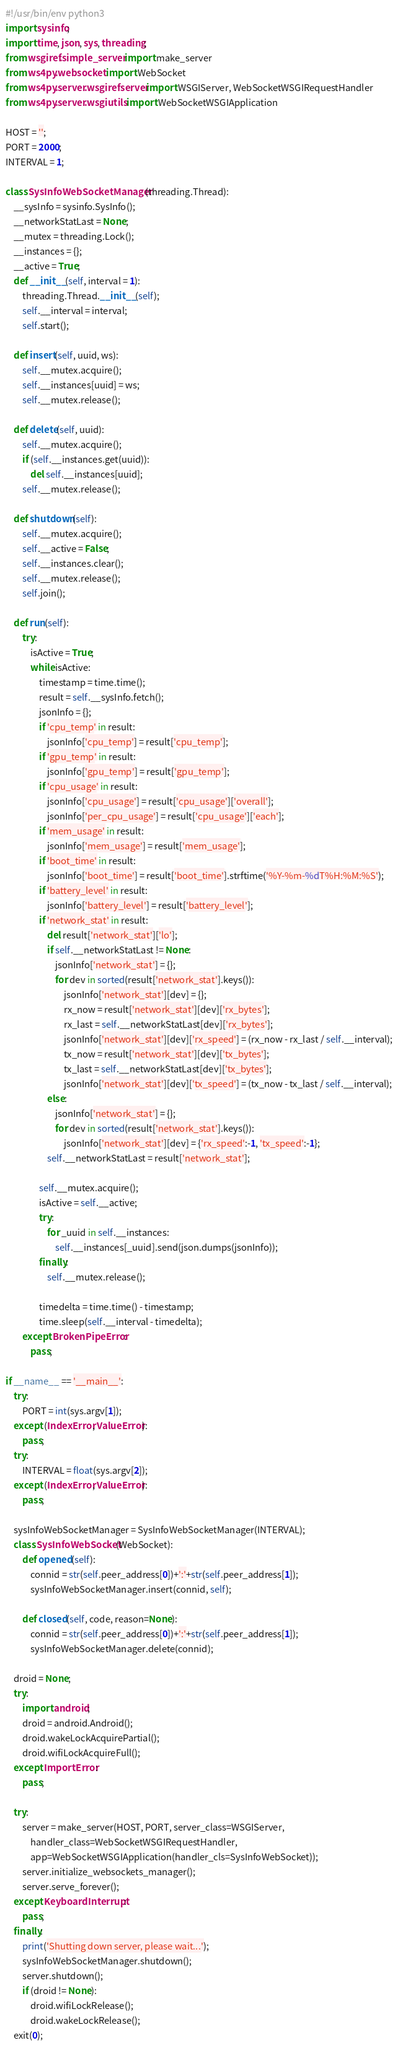Convert code to text. <code><loc_0><loc_0><loc_500><loc_500><_Python_>#!/usr/bin/env python3
import sysinfo;
import time, json, sys, threading;
from wsgiref.simple_server import make_server
from ws4py.websocket import WebSocket
from ws4py.server.wsgirefserver import WSGIServer, WebSocketWSGIRequestHandler
from ws4py.server.wsgiutils import WebSocketWSGIApplication

HOST = '';
PORT = 2000;
INTERVAL = 1;

class SysInfoWebSocketManager(threading.Thread):
    __sysInfo = sysinfo.SysInfo();
    __networkStatLast = None;
    __mutex = threading.Lock();
    __instances = {};
    __active = True;
    def __init__(self, interval = 1):
        threading.Thread.__init__(self);
        self.__interval = interval;
        self.start();

    def insert(self, uuid, ws):
        self.__mutex.acquire();
        self.__instances[uuid] = ws;
        self.__mutex.release();

    def delete(self, uuid):
        self.__mutex.acquire();
        if (self.__instances.get(uuid)):
            del self.__instances[uuid];
        self.__mutex.release();

    def shutdown(self):
        self.__mutex.acquire();
        self.__active = False;
        self.__instances.clear();
        self.__mutex.release();
        self.join();

    def run(self):
        try:
            isActive = True;
            while isActive:
                timestamp = time.time();
                result = self.__sysInfo.fetch();
                jsonInfo = {};
                if 'cpu_temp' in result:
                    jsonInfo['cpu_temp'] = result['cpu_temp'];
                if 'gpu_temp' in result:
                    jsonInfo['gpu_temp'] = result['gpu_temp'];
                if 'cpu_usage' in result:
                    jsonInfo['cpu_usage'] = result['cpu_usage']['overall'];
                    jsonInfo['per_cpu_usage'] = result['cpu_usage']['each'];
                if 'mem_usage' in result:
                    jsonInfo['mem_usage'] = result['mem_usage'];
                if 'boot_time' in result:
                    jsonInfo['boot_time'] = result['boot_time'].strftime('%Y-%m-%dT%H:%M:%S');
                if 'battery_level' in result:
                    jsonInfo['battery_level'] = result['battery_level'];
                if 'network_stat' in result:
                    del result['network_stat']['lo'];
                    if self.__networkStatLast != None:
                        jsonInfo['network_stat'] = {};
                        for dev in sorted(result['network_stat'].keys()):
                            jsonInfo['network_stat'][dev] = {};
                            rx_now = result['network_stat'][dev]['rx_bytes'];
                            rx_last = self.__networkStatLast[dev]['rx_bytes'];
                            jsonInfo['network_stat'][dev]['rx_speed'] = (rx_now - rx_last / self.__interval);
                            tx_now = result['network_stat'][dev]['tx_bytes'];
                            tx_last = self.__networkStatLast[dev]['tx_bytes'];
                            jsonInfo['network_stat'][dev]['tx_speed'] = (tx_now - tx_last / self.__interval);
                    else:
                        jsonInfo['network_stat'] = {};
                        for dev in sorted(result['network_stat'].keys()):
                            jsonInfo['network_stat'][dev] = {'rx_speed':-1, 'tx_speed':-1};
                    self.__networkStatLast = result['network_stat'];

                self.__mutex.acquire();
                isActive = self.__active;
                try:
                    for _uuid in self.__instances:
                        self.__instances[_uuid].send(json.dumps(jsonInfo));
                finally:
                    self.__mutex.release();

                timedelta = time.time() - timestamp;
                time.sleep(self.__interval - timedelta);
        except BrokenPipeError:
            pass;

if __name__ == '__main__':
    try:
        PORT = int(sys.argv[1]);
    except (IndexError, ValueError):
        pass;
    try:
        INTERVAL = float(sys.argv[2]);
    except (IndexError, ValueError):
        pass;

    sysInfoWebSocketManager = SysInfoWebSocketManager(INTERVAL);
    class SysInfoWebSocket(WebSocket):
        def opened(self):
            connid = str(self.peer_address[0])+':'+str(self.peer_address[1]);
            sysInfoWebSocketManager.insert(connid, self);

        def closed(self, code, reason=None):
            connid = str(self.peer_address[0])+':'+str(self.peer_address[1]);
            sysInfoWebSocketManager.delete(connid);

    droid = None;
    try:
        import android;
        droid = android.Android();
        droid.wakeLockAcquirePartial();
        droid.wifiLockAcquireFull();
    except ImportError:
        pass;

    try:
        server = make_server(HOST, PORT, server_class=WSGIServer,
            handler_class=WebSocketWSGIRequestHandler,
            app=WebSocketWSGIApplication(handler_cls=SysInfoWebSocket));
        server.initialize_websockets_manager();
        server.serve_forever();
    except KeyboardInterrupt:
        pass;
    finally:
        print('Shutting down server, please wait...');
        sysInfoWebSocketManager.shutdown();
        server.shutdown();
        if (droid != None):
            droid.wifiLockRelease();
            droid.wakeLockRelease();
    exit(0);

</code> 